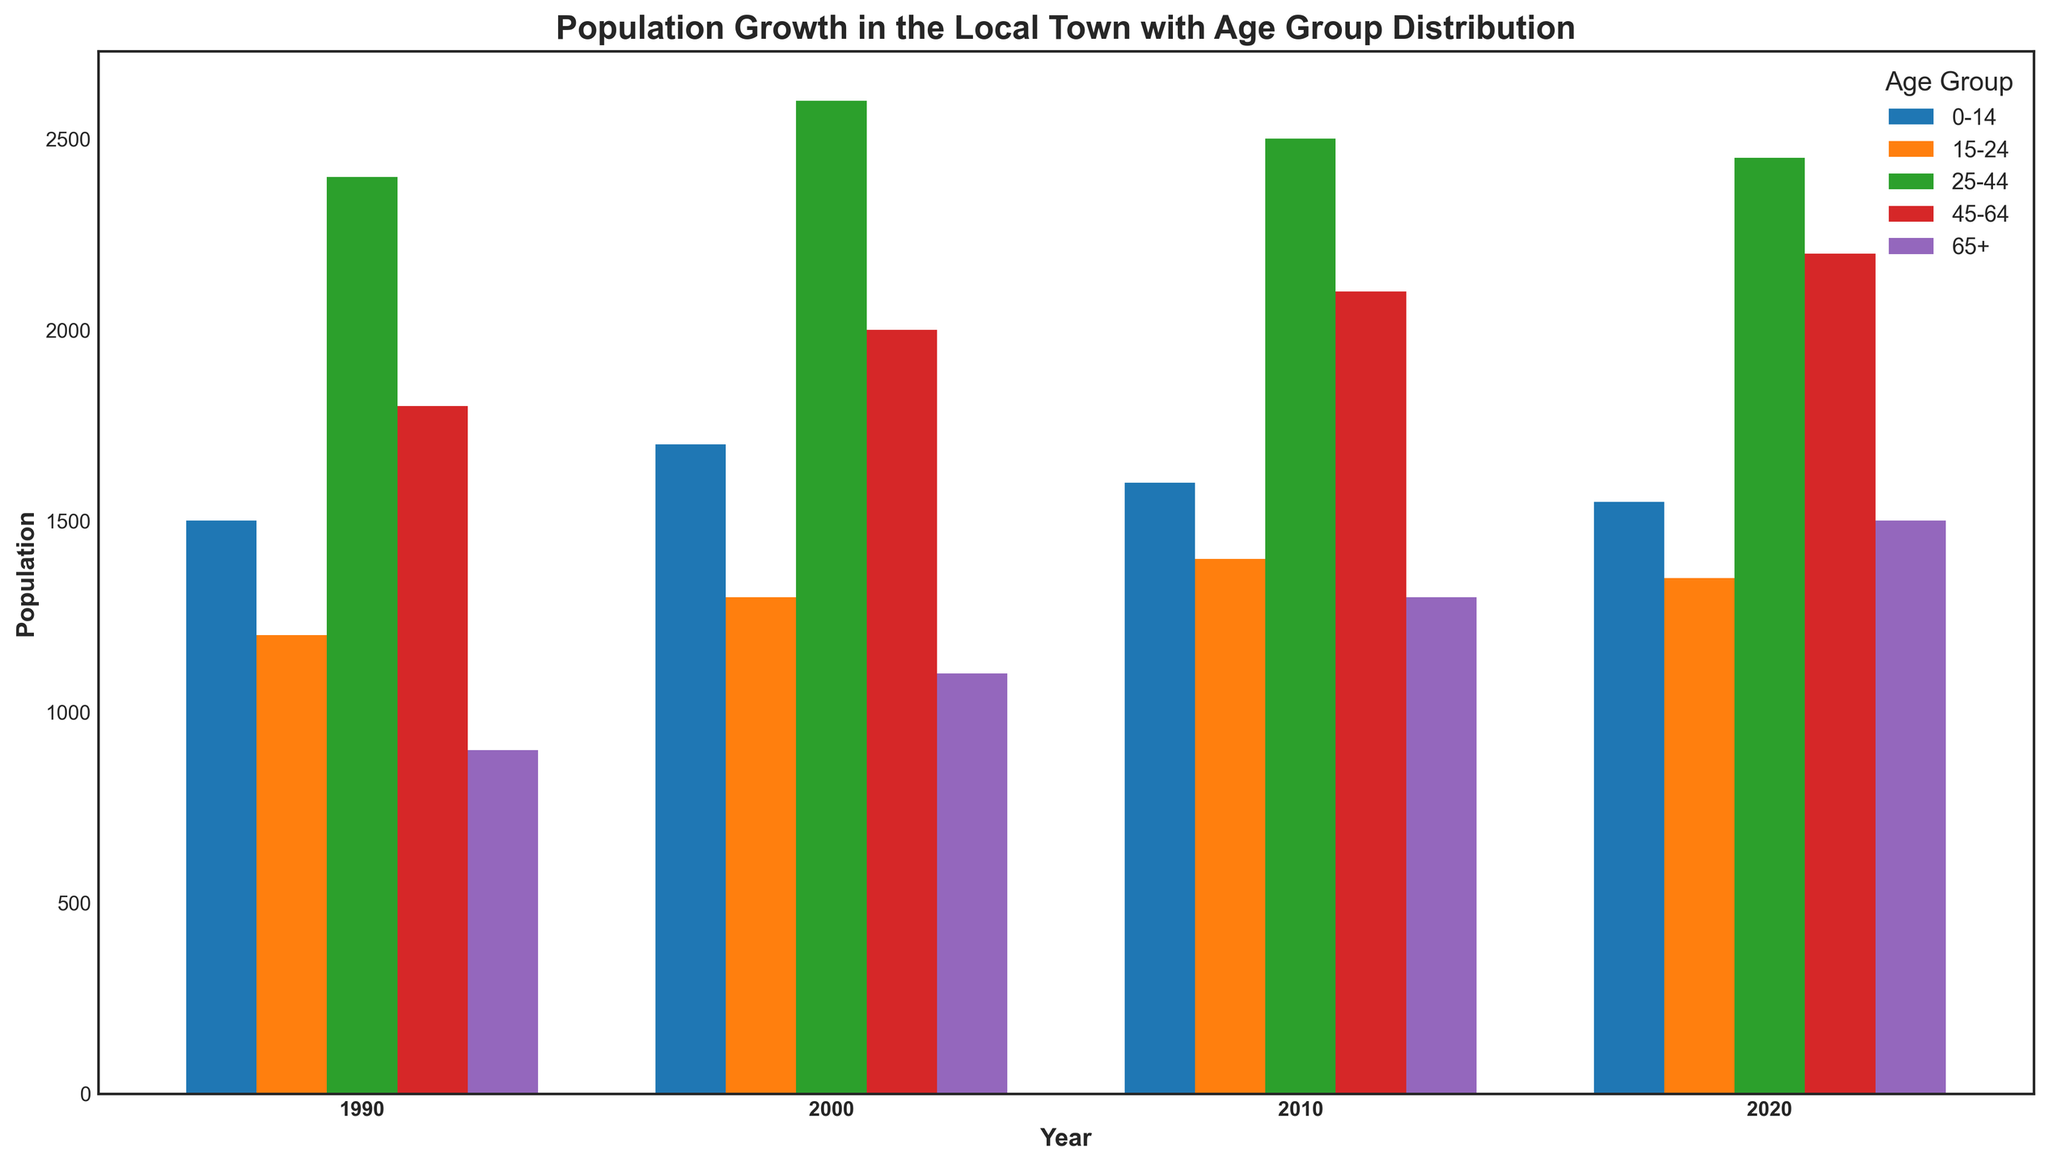Which age group had the highest population in 1990? Locate the year 1990 on the x-axis, then compare the heights of the bars for each age group to determine the highest one. The tallest bar corresponds to the 25-44 age group.
Answer: 25-44 How did the population of the 65+ age group change from 1990 to 2020? Observe the heights of the 65+ age group bars for the years 1990 and 2020. The population increased from 900 in 1990 to 1500 in 2020.
Answer: Increased by 600 What is the overall trend of the 0-14 age group from 1990 to 2020? Compare the bars corresponding to the 0-14 age group across the years 1990, 2000, 2010, and 2020. The population increased initially from 1500 in 1990 to 1700 in 2000, then slightly decreased to 1600 in 2010, and further dropped to 1550 in 2020.
Answer: Decreased Which age group's population remained relatively stable from 1990 to 2020? Examine the height of each age group's bars from 1990 to 2020. The 25-44 age group had minor changes, starting at 2400 in 1990 and ending at 2450 in 2020.
Answer: 25-44 What was the combined population of the 45-64 and 65+ age groups in 2010? Refer to the bars for 2010, add the populations of the 45-64 group (2100) and 65+ group (1300). The sum is 2100 + 1300 = 3400.
Answer: 3400 Which year had the highest total population across all age groups? For each year, sum the populations of all age groups: 
- 1990: 1500 + 1200 + 2400 + 1800 + 900 = 7800
- 2000: 1700 + 1300 + 2600 + 2000 + 1100 = 8700
- 2010: 1600 + 1400 + 2500 + 2100 + 1300 = 8900
- 2020: 1550 + 1350 + 2450 + 2200 + 1500 = 9050
The year 2020 has the highest total population.
Answer: 2020 Which age group saw the greatest increase in population between 2000 and 2020? Calculate the difference in population for each age group between 2000 and 2020:
- 0-14: 1550 - 1700 = -150 (decrease)
- 15-24: 1350 - 1300 = 50
- 25-44: 2450 - 2600 = -150 (decrease)
- 45-64: 2200 - 2000 = 200
- 65+: 1500 - 1100 = 400
The 65+ age group saw the greatest increase of 400 people.
Answer: 65+ In which year did the 15-24 age group have the lowest population? Examine the bars for the 15-24 age group across all years. The height is lowest in 1990 with a population of 1200.
Answer: 1990 How does the population change of the 0-14 and 45-64 age groups from 1990 to 2020 compare? Calculate the difference for both age groups:
- 0-14: 1550 - 1500 = 50 (increase)
- 45-64: 2200 - 1800 = 400 (increase)
The 45-64 age group saw a larger increase of 400 compared to the 0-14's increase of 50.
Answer: 45-64 increased more Which age group had the most stable population between 1990 and 2020? Determine the range of populations over the years for each age group by finding the difference between their maximum and minimum values:
- 0-14: 1700 - 1500 = 200
- 15-24: 1400 - 1200 = 200
- 25-44: 2600 - 2400 = 200
- 45-64: 2200 - 1800 = 400
- 65+: 1500 - 900 = 600
All age groups except 45-64 and 65+ have the same range of 200, indicating relative stability.
Answer: 0-14, 15-24, and 25-44 